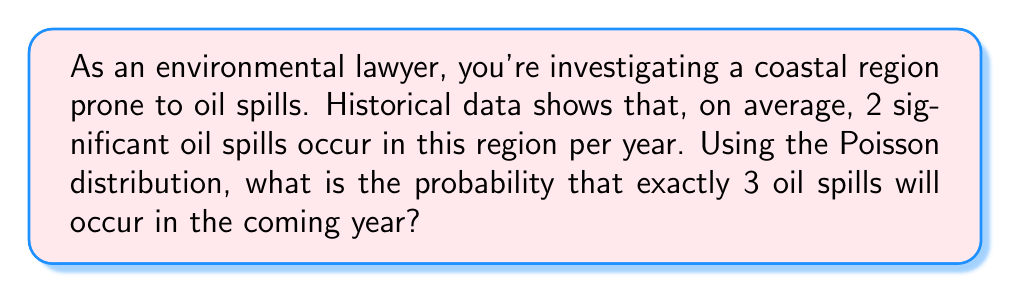Help me with this question. To solve this problem, we'll use the Poisson distribution, which is often used to model the number of events occurring in a fixed interval of time or space when these events happen with a known average rate and independently of each other.

The Poisson probability mass function is given by:

$$P(X = k) = \frac{e^{-\lambda} \lambda^k}{k!}$$

Where:
$\lambda$ = average rate of events
$k$ = number of events we're calculating the probability for
$e$ = Euler's number (approximately 2.71828)

Given:
$\lambda = 2$ (average of 2 oil spills per year)
$k = 3$ (we're calculating the probability of exactly 3 oil spills)

Let's substitute these values into the formula:

$$P(X = 3) = \frac{e^{-2} 2^3}{3!}$$

Now, let's calculate step by step:

1) First, calculate $e^{-2}$:
   $e^{-2} \approx 0.1353$

2) Calculate $2^3$:
   $2^3 = 8$

3) Calculate $3!$:
   $3! = 3 \times 2 \times 1 = 6$

4) Now, put it all together:
   $$P(X = 3) = \frac{0.1353 \times 8}{6} \approx 0.1804$$

Therefore, the probability of exactly 3 oil spills occurring in the coming year is approximately 0.1804 or 18.04%.
Answer: 0.1804 (or 18.04%) 